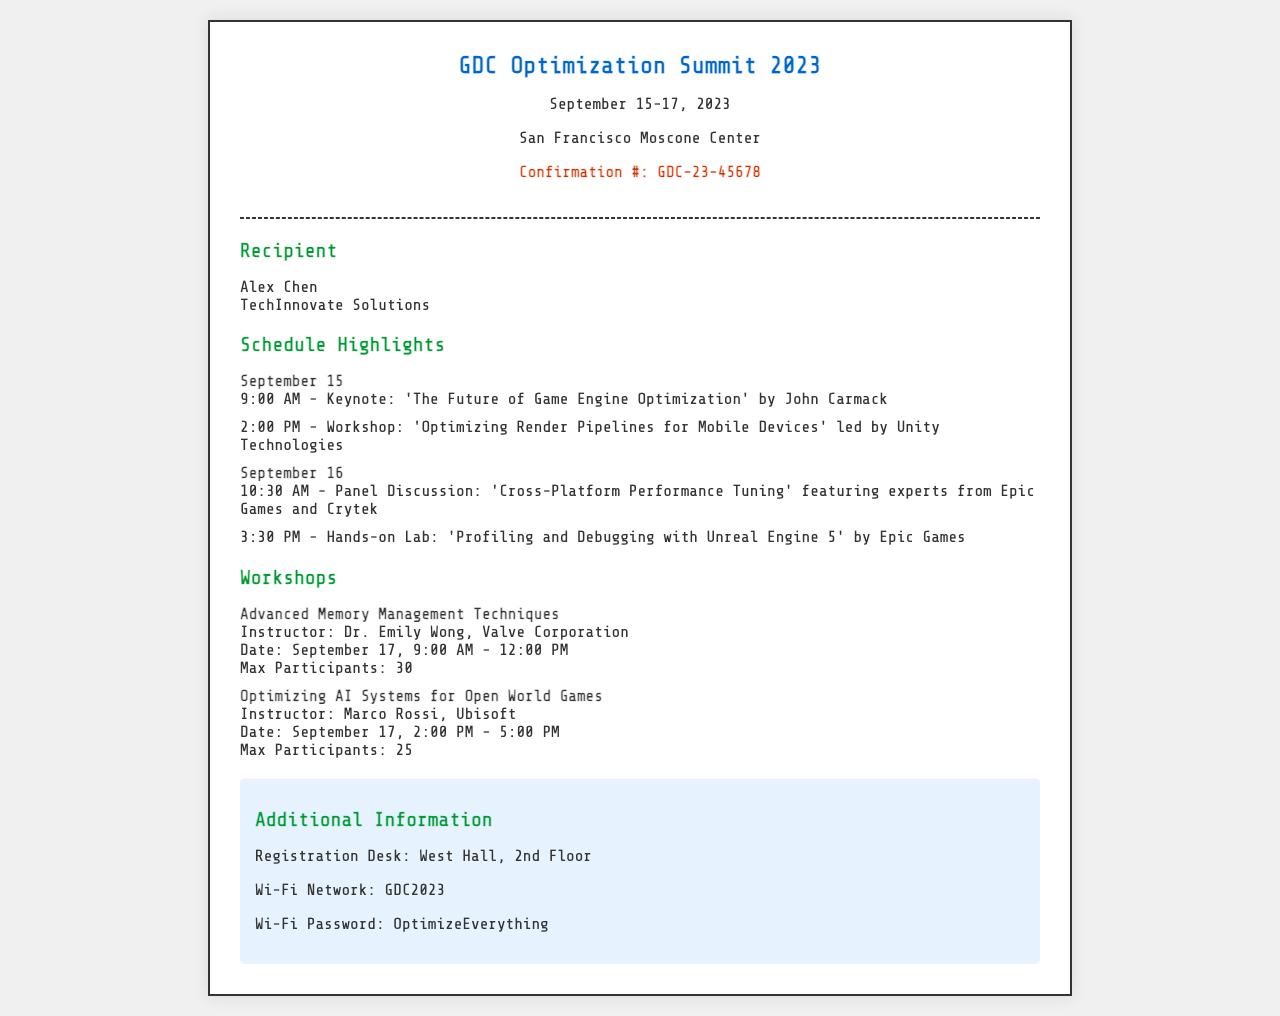What are the dates of the symposium? The dates of the symposium can be found in the header section of the document.
Answer: September 15-17, 2023 Who is the keynote speaker? The keynote speaker's name is listed under the September 15 schedule.
Answer: John Carmack What time is the workshop on optimizing render pipelines? The workshop time is specified in the schedule highlights section.
Answer: 2:00 PM How many max participants are allowed in the "Optimizing AI Systems for Open World Games" workshop? The maximum number of participants is mentioned directly in the workshop's description.
Answer: 25 Where is the registration desk located? The location of the registration desk is noted in the additional information section.
Answer: West Hall, 2nd Floor What is the Wi-Fi password? The Wi-Fi password is provided in the additional information section.
Answer: OptimizeEverything What is the title of the panel discussion? The title of the panel discussion is found in the schedule for September 16.
Answer: Cross-Platform Performance Tuning Who is the instructor for the "Advanced Memory Management Techniques" workshop? The instructor's name is included in the workshop description.
Answer: Dr. Emily Wong What type of document is this? The document is a fax confirmation for a conference registration.
Answer: Fax confirmation 